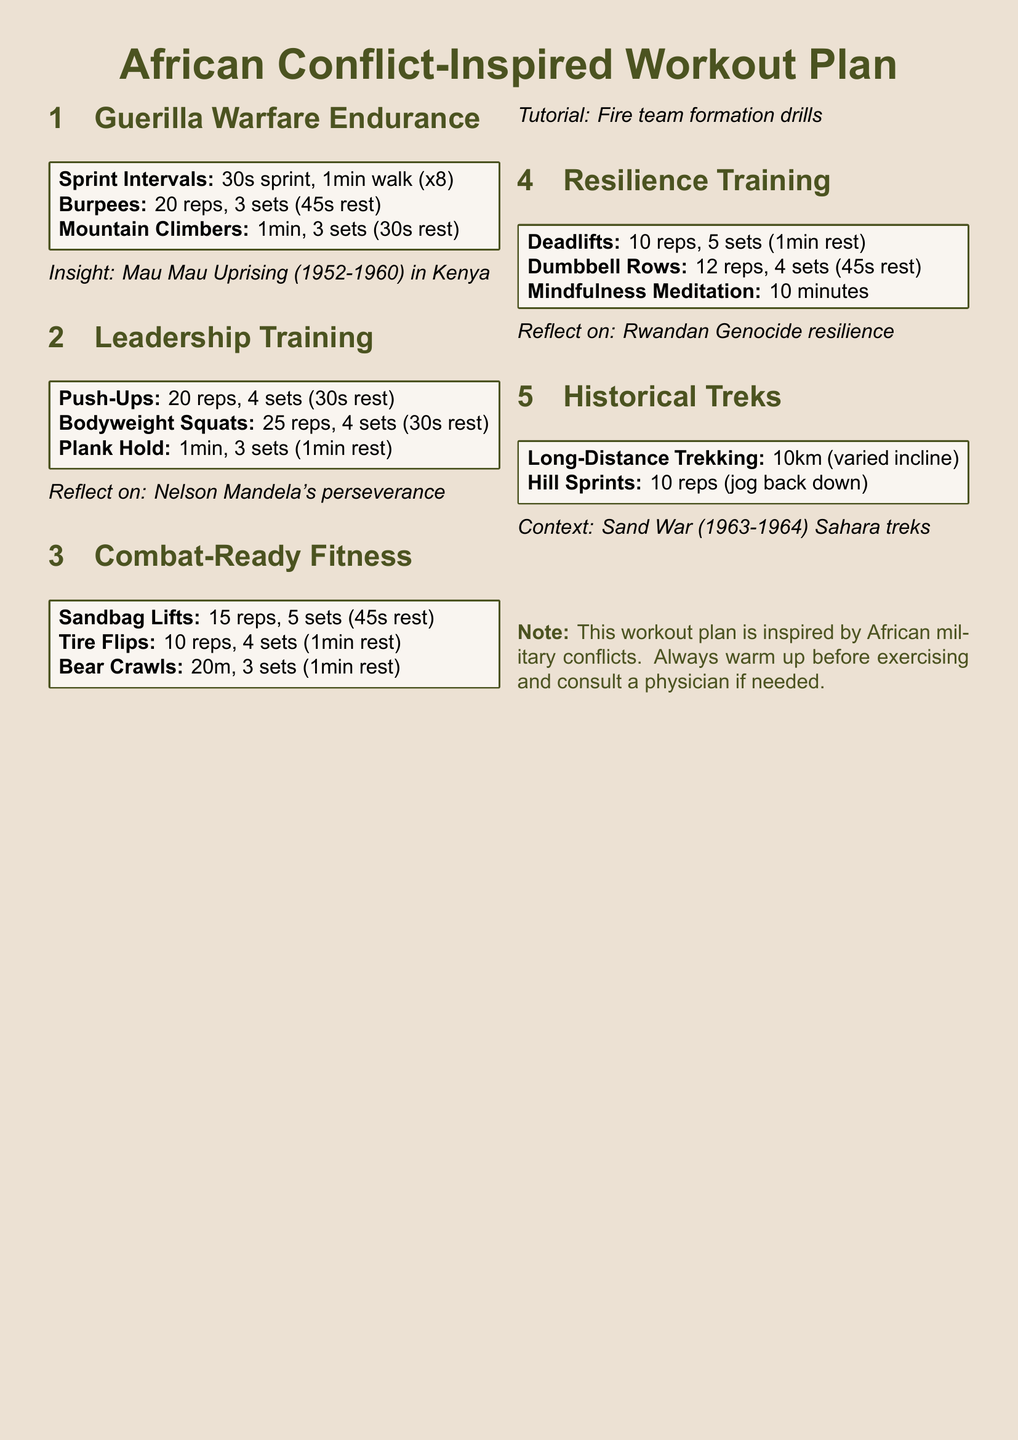What is the first exercise listed under Guerilla Warfare Endurance? The first exercise is Sprint Intervals, which includes 30s sprint and 1min walk for 8 repetitions.
Answer: Sprint Intervals How long is the mindfulness meditation exercise in the Resilience Training section? The mindfulness meditation exercise is listed for 10 minutes.
Answer: 10 minutes How many sets of tire flips are included in the Combat-Ready Fitness regimen? Tire flips are included for 4 sets in the workout plan.
Answer: 4 sets What historical conflict is used as an insight in the Guerilla Warfare Endurance section? The historical conflict referenced is the Mau Mau Uprising occurring in Kenya from 1952 to 1960.
Answer: Mau Mau Uprising (1952-1960) What is one key leadership figure mentioned in the Leadership Training section? The key leadership figure mentioned is Nelson Mandela.
Answer: Nelson Mandela What type of exercise is included in the Historical Treks section? The exercise included is Long-Distance Trekking.
Answer: Long-Distance Trekking How many reps of deadlifts are prescribed in the Resilience Training section? The workout plan prescribes 10 reps for deadlifts.
Answer: 10 reps Which physical exercise from the Combat-Ready Fitness section involves lifting a heavy object? The exercise that involves lifting a heavy object is Sandbag Lifts.
Answer: Sandbag Lifts What is the context mentioned for the Historical Marches workout? The context mentioned is the Sand War, which occurred between 1963 and 1964.
Answer: Sand War (1963-1964) 